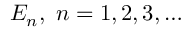<formula> <loc_0><loc_0><loc_500><loc_500>E _ { n } , \, n = 1 , 2 , 3 , \dots</formula> 